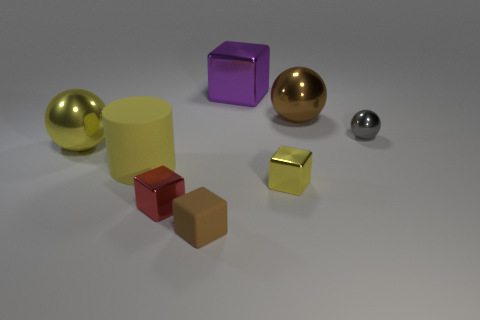What is the color of the rubber thing on the left side of the small red shiny object?
Make the answer very short. Yellow. There is a tiny block right of the purple metal thing; are there any purple shiny objects that are in front of it?
Your response must be concise. No. What number of other things are the same color as the large cylinder?
Your answer should be very brief. 2. There is a brown object that is behind the small yellow thing; does it have the same size as the matte object that is on the left side of the tiny brown matte object?
Your answer should be very brief. Yes. There is a brown thing in front of the metal sphere that is behind the gray thing; how big is it?
Your response must be concise. Small. What is the material of the large thing that is both on the right side of the large yellow metallic object and on the left side of the brown rubber thing?
Keep it short and to the point. Rubber. The matte block is what color?
Your answer should be compact. Brown. Is there any other thing that has the same material as the brown cube?
Your answer should be very brief. Yes. What shape is the tiny red object that is in front of the tiny metallic sphere?
Provide a short and direct response. Cube. There is a cube that is behind the large shiny sphere behind the small gray thing; are there any rubber objects to the right of it?
Ensure brevity in your answer.  No. 